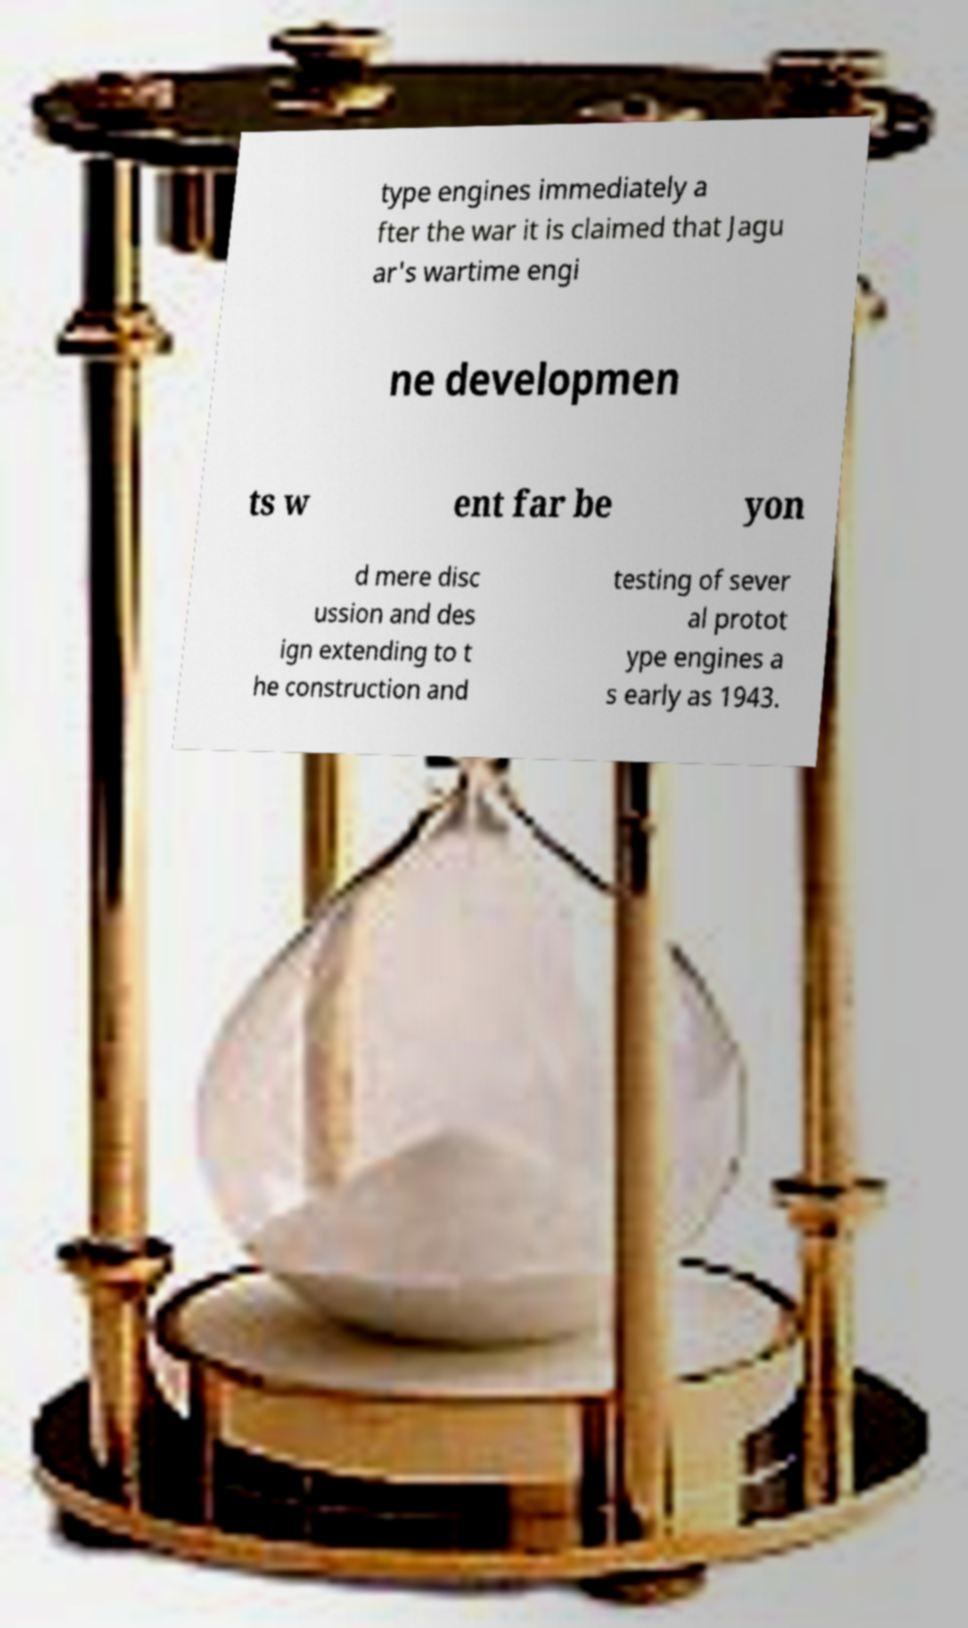There's text embedded in this image that I need extracted. Can you transcribe it verbatim? type engines immediately a fter the war it is claimed that Jagu ar's wartime engi ne developmen ts w ent far be yon d mere disc ussion and des ign extending to t he construction and testing of sever al protot ype engines a s early as 1943. 